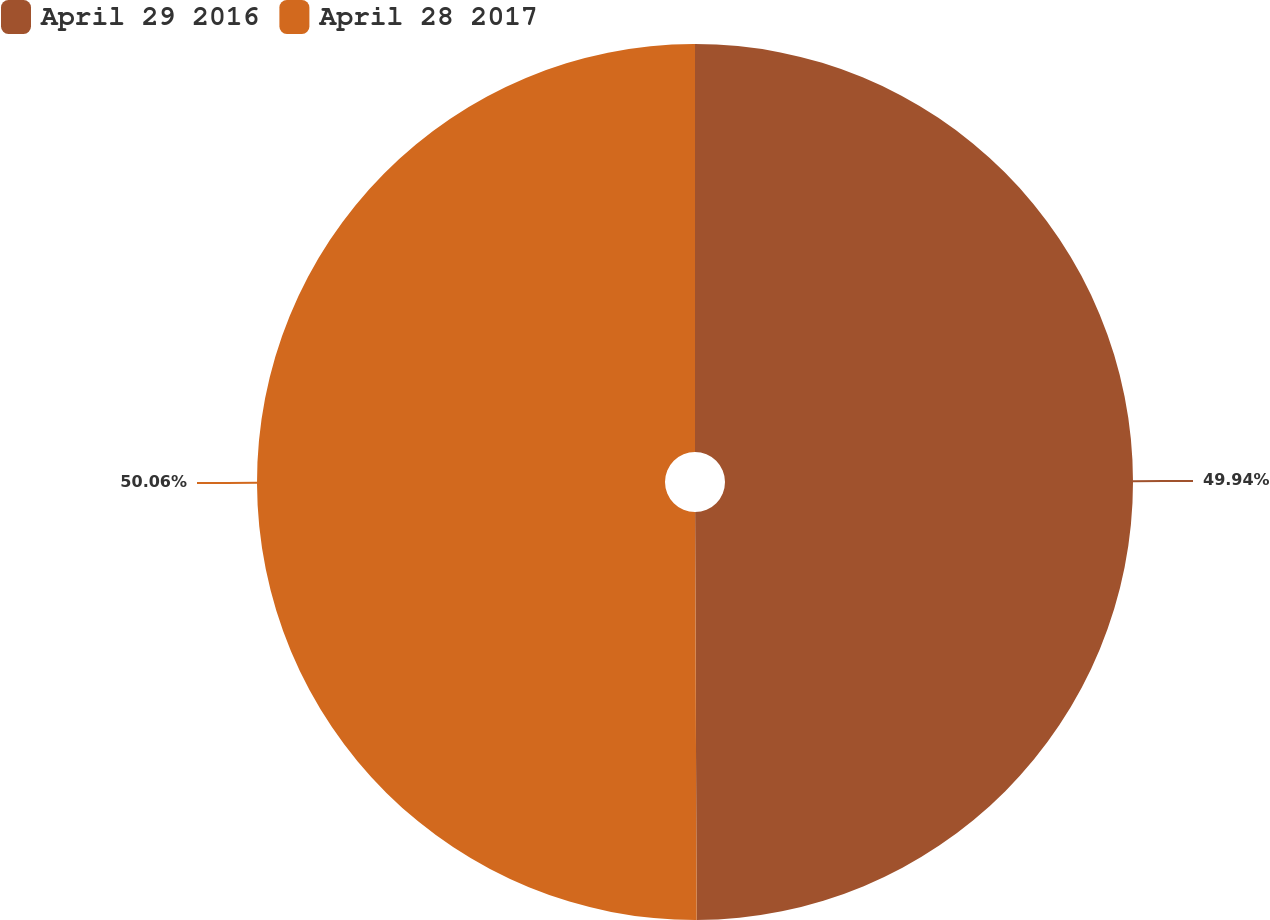Convert chart to OTSL. <chart><loc_0><loc_0><loc_500><loc_500><pie_chart><fcel>April 29 2016<fcel>April 28 2017<nl><fcel>49.94%<fcel>50.06%<nl></chart> 